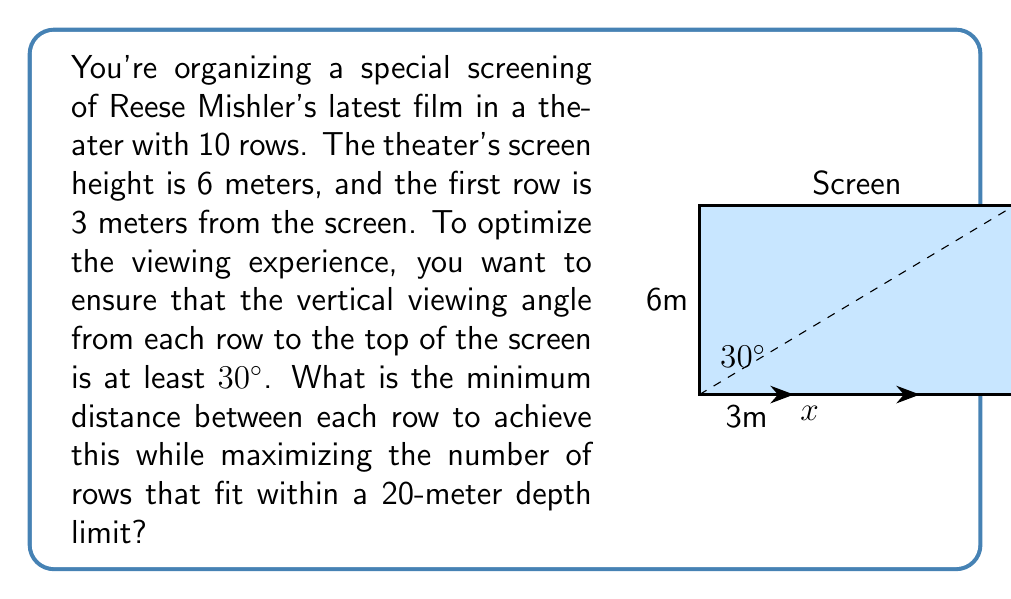Help me with this question. Let's approach this step-by-step:

1) Let $x$ be the distance between each row.

2) The tangent of the viewing angle for the last row should be at least tan(30°):

   $$\tan(30°) \leq \frac{6}{3 + 9x}$$

3) We know that $\tan(30°) = \frac{1}{\sqrt{3}} \approx 0.577$

4) Substituting this:

   $$\frac{1}{\sqrt{3}} \leq \frac{6}{3 + 9x}$$

5) Solving for $x$:

   $$3 + 9x \leq 6\sqrt{3}$$
   $$9x \leq 6\sqrt{3} - 3$$
   $$x \leq \frac{6\sqrt{3} - 3}{9} \approx 0.8454$$

6) The total depth of the theater is $3 + 9x \leq 20$

7) Solving this inequality:

   $$9x \leq 17$$
   $$x \leq \frac{17}{9} \approx 1.8889$$

8) To maximize the number of rows while meeting both conditions, we need to choose the largest $x$ that satisfies both inequalities. This is $x = \frac{6\sqrt{3} - 3}{9} \approx 0.8454$ meters.
Answer: $\frac{6\sqrt{3} - 3}{9}$ meters (approximately 0.8454 meters) 